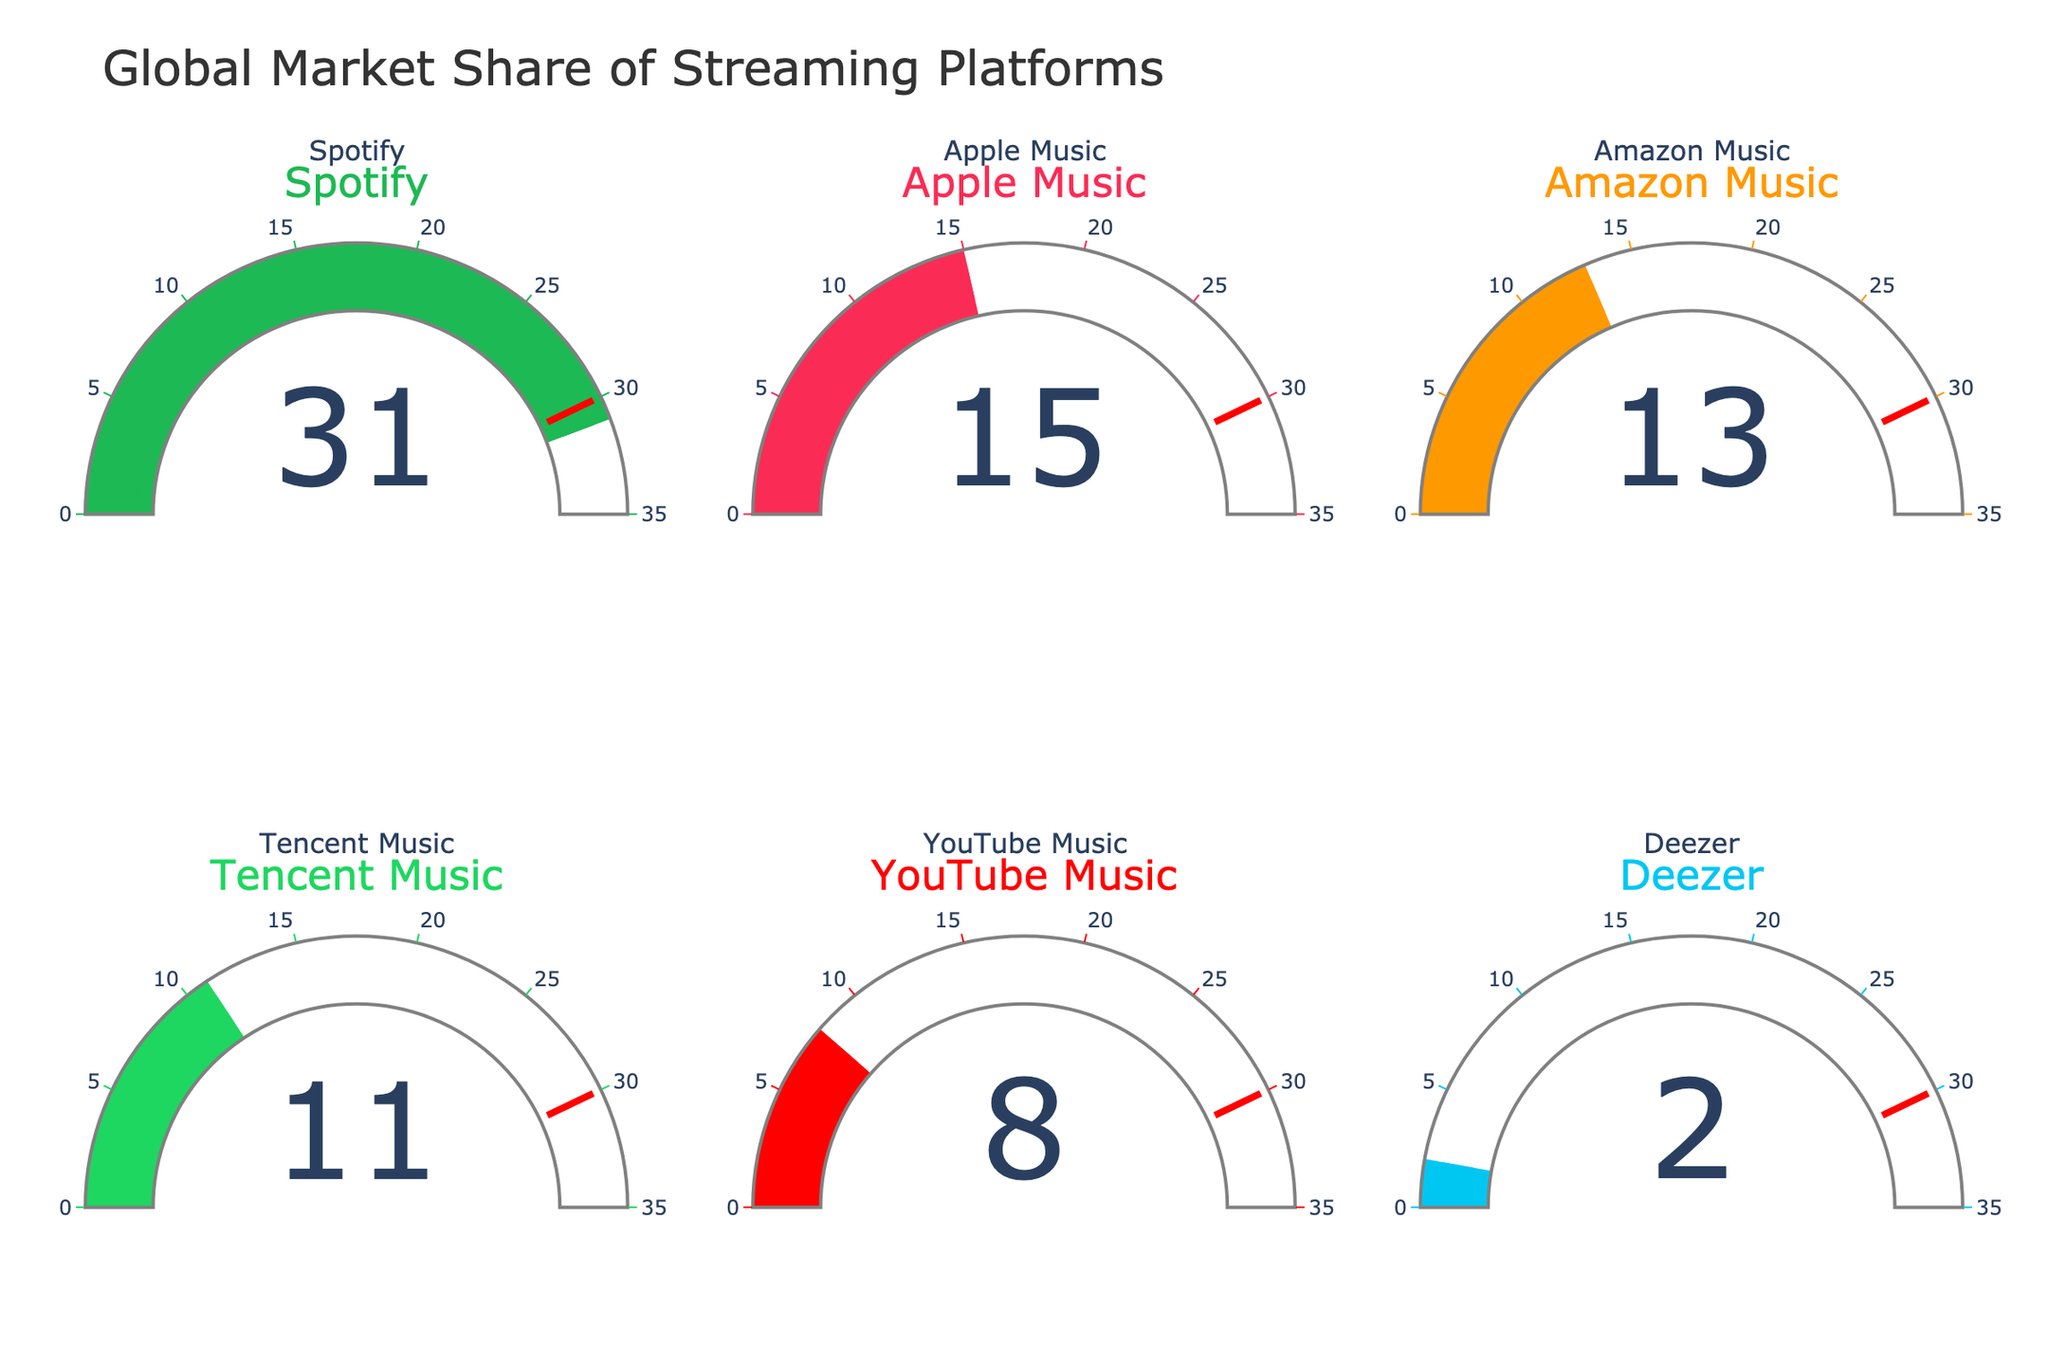Which streaming platform has the highest global market share? The figure shows individual gauges for each streaming platform. By comparing the numbers, it's clear that Spotify has the highest value on its gauge.
Answer: Spotify Which streaming platform has the second-highest global market share? The figure shows individual gauges for each streaming platform. After Spotify, Apple Music has the next highest value.
Answer: Apple Music What is the total market share of Spotify and Apple Music combined? From the gauges, Spotify has a 31% share and Apple Music has a 15% share. Adding them together: 31% + 15% = 46%
Answer: 46% How much more market share does Spotify have compared to YouTube Music? Spotify's gauge shows 31% and YouTube Music's gauge shows 8%. Subtracting YouTube Music's share from Spotify's: 31% - 8% = 23%
Answer: 23% How many streaming platforms have a market share of at least 10%? From the gauges, Spotify, Apple Music, Amazon Music, and Tencent Music each have market shares of 31%, 15%, 13%, and 11% respectively. That makes four platforms.
Answer: 4 What is the smallest market share shown in the figure? By looking at the gauges, Deezer has the smallest value, which is 2%.
Answer: 2% Is Amazon Music’s market share closer to that of Apple Music or Tencent Music? Amazon Music has a 13% market share. The difference with Apple Music is 15% - 13% = 2%, and with Tencent Music, it is 13% - 11% = 2%. The differences are equal.
Answer: Equal Calculate the average market share of all streaming platforms shown. Summing up the market shares: 31% + 15% + 13% + 11% + 8% + 2% = 80%. There are six platforms, so the average is 80% / 6 ≈ 13.33%.
Answer: 13.33% Does any platform exceed the 30% threshold set by the gauge’s threshold marker? The threshold marker on the gauges is set at 30%. Only Spotify's gauge has a value (31%) above this marker.
Answer: Yes 